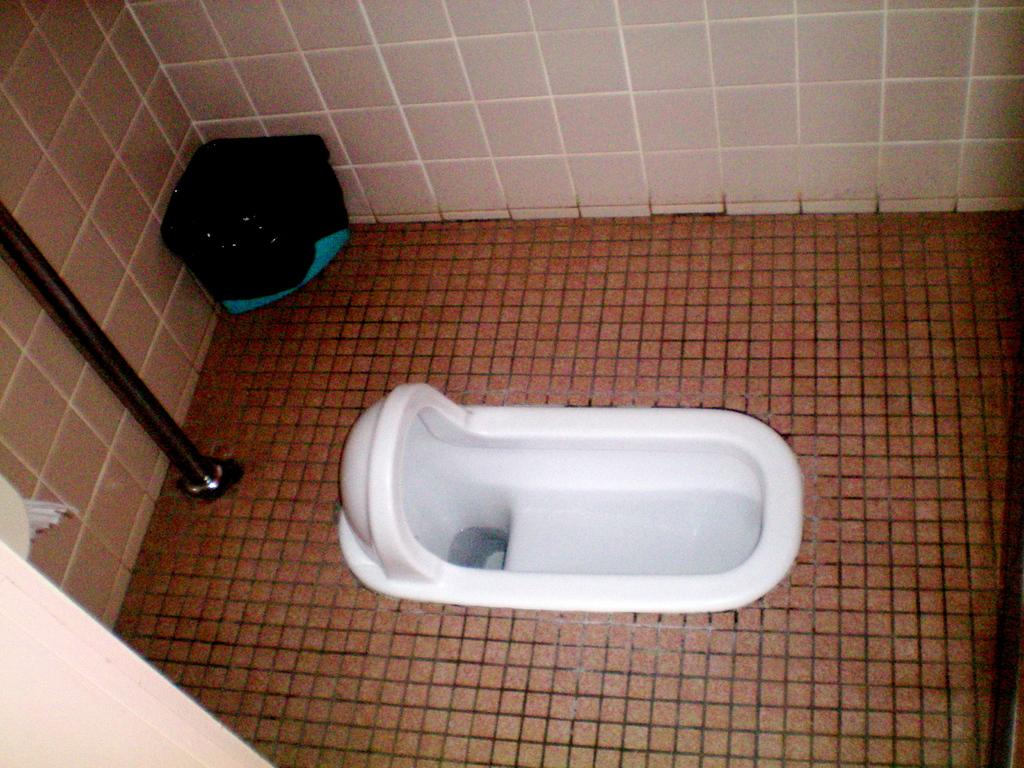What type of room is the image taken in? The image is taken in a bathroom. What is the main fixture in the center of the image? There is a toilet in the center of the image. What can be seen in the background of the image? There is a wall and a bin in the background of the image. What object is present in the image that is typically used for hanging items? There is a rod in the image. What type of cave can be seen in the background of the image? There is no cave present in the image; it is taken in a bathroom with a wall and a bin in the background. 